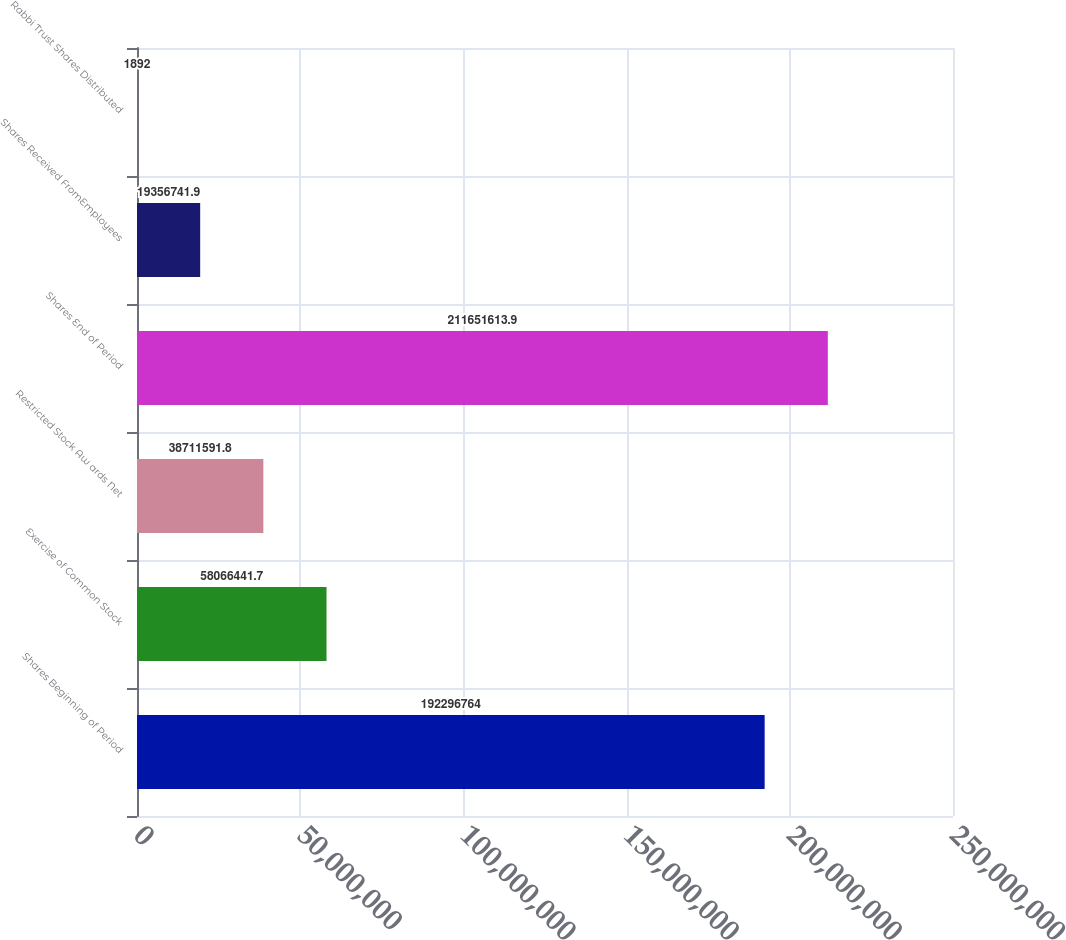Convert chart to OTSL. <chart><loc_0><loc_0><loc_500><loc_500><bar_chart><fcel>Shares Beginning of Period<fcel>Exercise of Common Stock<fcel>Restricted Stock Aw ards Net<fcel>Shares End of Period<fcel>Shares Received FromEmployees<fcel>Rabbi Trust Shares Distributed<nl><fcel>1.92297e+08<fcel>5.80664e+07<fcel>3.87116e+07<fcel>2.11652e+08<fcel>1.93567e+07<fcel>1892<nl></chart> 